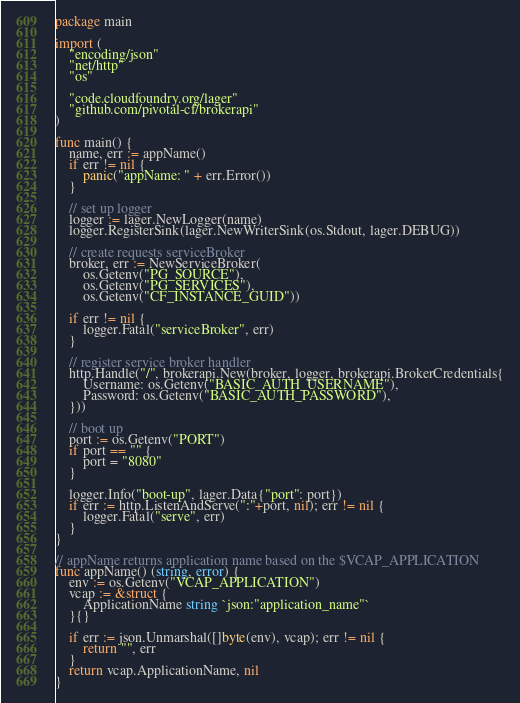<code> <loc_0><loc_0><loc_500><loc_500><_Go_>package main

import (
	"encoding/json"
	"net/http"
	"os"

	"code.cloudfoundry.org/lager"
	"github.com/pivotal-cf/brokerapi"
)

func main() {
	name, err := appName()
	if err != nil {
		panic("appName: " + err.Error())
	}

	// set up logger
	logger := lager.NewLogger(name)
	logger.RegisterSink(lager.NewWriterSink(os.Stdout, lager.DEBUG))

	// create requests serviceBroker
	broker, err := NewServiceBroker(
		os.Getenv("PG_SOURCE"),
		os.Getenv("PG_SERVICES"),
		os.Getenv("CF_INSTANCE_GUID"))

	if err != nil {
		logger.Fatal("serviceBroker", err)
	}

	// register service broker handler
	http.Handle("/", brokerapi.New(broker, logger, brokerapi.BrokerCredentials{
		Username: os.Getenv("BASIC_AUTH_USERNAME"),
		Password: os.Getenv("BASIC_AUTH_PASSWORD"),
	}))

	// boot up
	port := os.Getenv("PORT")
	if port == "" {
		port = "8080"
	}

	logger.Info("boot-up", lager.Data{"port": port})
	if err := http.ListenAndServe(":"+port, nil); err != nil {
		logger.Fatal("serve", err)
	}
}

// appName returns application name based on the $VCAP_APPLICATION
func appName() (string, error) {
	env := os.Getenv("VCAP_APPLICATION")
	vcap := &struct {
		ApplicationName string `json:"application_name"`
	}{}

	if err := json.Unmarshal([]byte(env), vcap); err != nil {
		return "", err
	}
	return vcap.ApplicationName, nil
}
</code> 